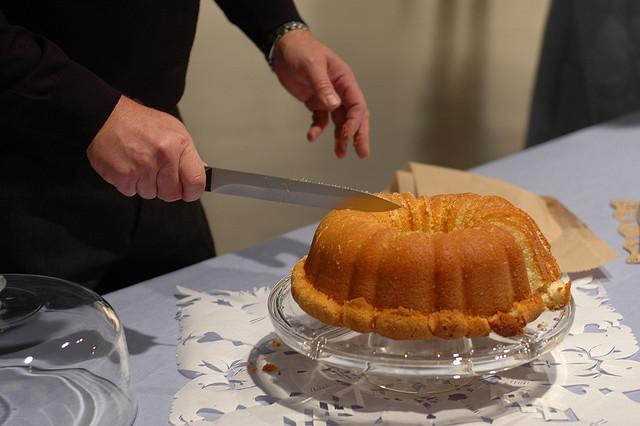What type of cake is this? bundt 